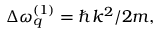Convert formula to latex. <formula><loc_0><loc_0><loc_500><loc_500>\Delta \omega _ { q } ^ { ( 1 ) } = \hbar { k } ^ { 2 } / 2 m ,</formula> 